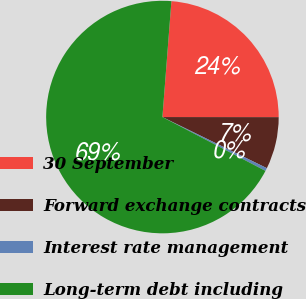Convert chart to OTSL. <chart><loc_0><loc_0><loc_500><loc_500><pie_chart><fcel>30 September<fcel>Forward exchange contracts<fcel>Interest rate management<fcel>Long-term debt including<nl><fcel>23.78%<fcel>7.23%<fcel>0.42%<fcel>68.57%<nl></chart> 